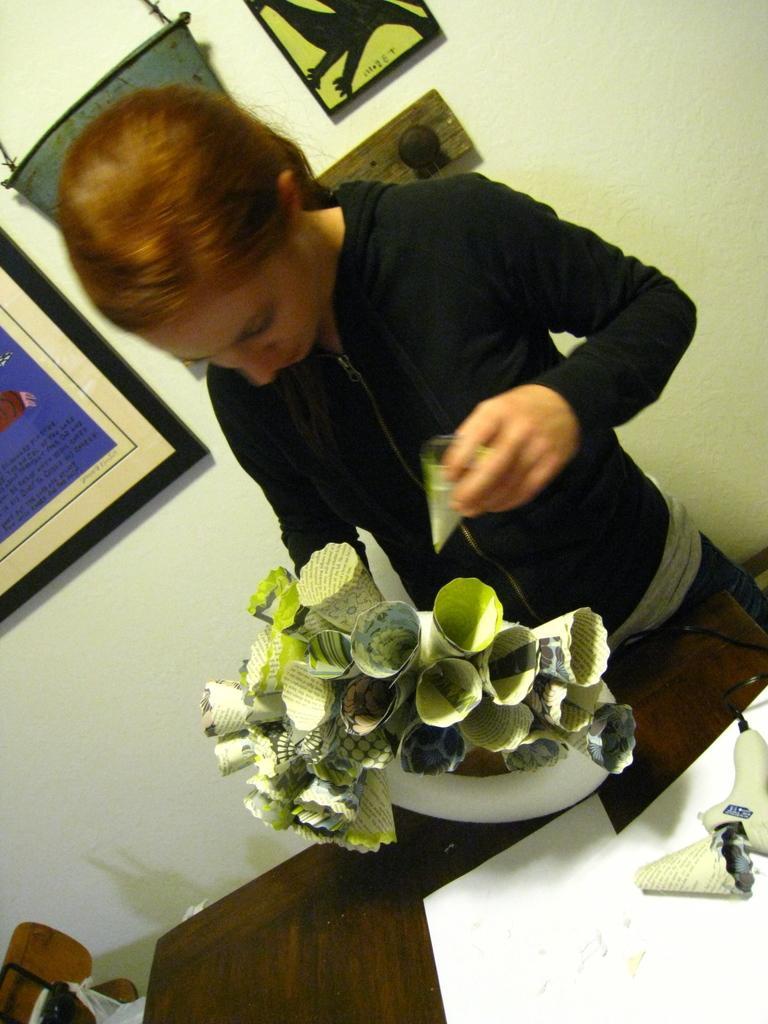Please provide a concise description of this image. In the picture we can see a woman standing near the table and arranging some cones and she is with a black color jacket and behind her we can see a wall with some photo frames to it. 